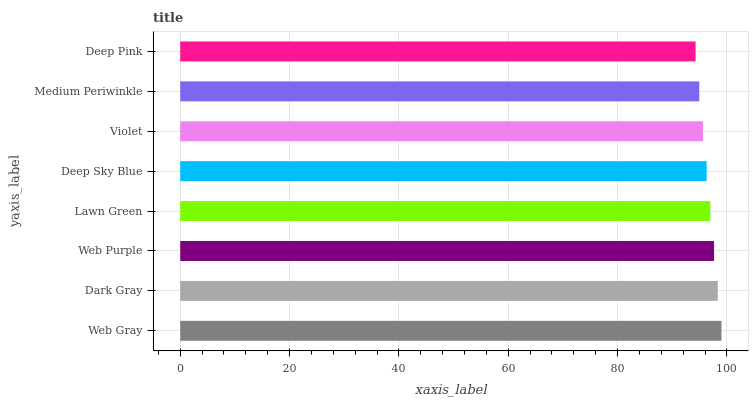Is Deep Pink the minimum?
Answer yes or no. Yes. Is Web Gray the maximum?
Answer yes or no. Yes. Is Dark Gray the minimum?
Answer yes or no. No. Is Dark Gray the maximum?
Answer yes or no. No. Is Web Gray greater than Dark Gray?
Answer yes or no. Yes. Is Dark Gray less than Web Gray?
Answer yes or no. Yes. Is Dark Gray greater than Web Gray?
Answer yes or no. No. Is Web Gray less than Dark Gray?
Answer yes or no. No. Is Lawn Green the high median?
Answer yes or no. Yes. Is Deep Sky Blue the low median?
Answer yes or no. Yes. Is Deep Pink the high median?
Answer yes or no. No. Is Medium Periwinkle the low median?
Answer yes or no. No. 